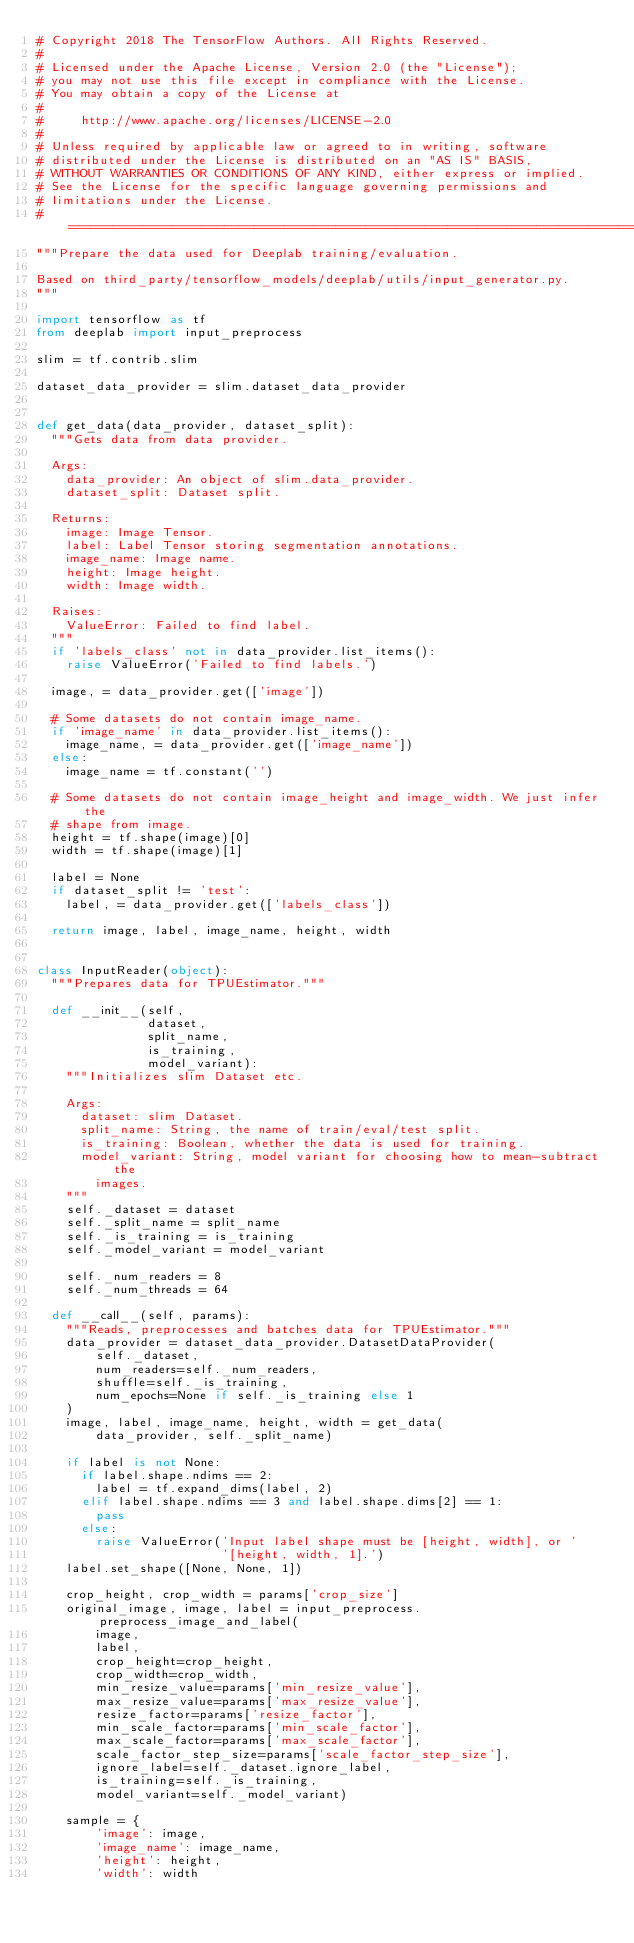<code> <loc_0><loc_0><loc_500><loc_500><_Python_># Copyright 2018 The TensorFlow Authors. All Rights Reserved.
#
# Licensed under the Apache License, Version 2.0 (the "License");
# you may not use this file except in compliance with the License.
# You may obtain a copy of the License at
#
#     http://www.apache.org/licenses/LICENSE-2.0
#
# Unless required by applicable law or agreed to in writing, software
# distributed under the License is distributed on an "AS IS" BASIS,
# WITHOUT WARRANTIES OR CONDITIONS OF ANY KIND, either express or implied.
# See the License for the specific language governing permissions and
# limitations under the License.
# ==============================================================================
"""Prepare the data used for Deeplab training/evaluation.

Based on third_party/tensorflow_models/deeplab/utils/input_generator.py.
"""

import tensorflow as tf
from deeplab import input_preprocess

slim = tf.contrib.slim

dataset_data_provider = slim.dataset_data_provider


def get_data(data_provider, dataset_split):
  """Gets data from data provider.

  Args:
    data_provider: An object of slim.data_provider.
    dataset_split: Dataset split.

  Returns:
    image: Image Tensor.
    label: Label Tensor storing segmentation annotations.
    image_name: Image name.
    height: Image height.
    width: Image width.

  Raises:
    ValueError: Failed to find label.
  """
  if 'labels_class' not in data_provider.list_items():
    raise ValueError('Failed to find labels.')

  image, = data_provider.get(['image'])

  # Some datasets do not contain image_name.
  if 'image_name' in data_provider.list_items():
    image_name, = data_provider.get(['image_name'])
  else:
    image_name = tf.constant('')

  # Some datasets do not contain image_height and image_width. We just infer the
  # shape from image.
  height = tf.shape(image)[0]
  width = tf.shape(image)[1]

  label = None
  if dataset_split != 'test':
    label, = data_provider.get(['labels_class'])

  return image, label, image_name, height, width


class InputReader(object):
  """Prepares data for TPUEstimator."""

  def __init__(self,
               dataset,
               split_name,
               is_training,
               model_variant):
    """Initializes slim Dataset etc.

    Args:
      dataset: slim Dataset.
      split_name: String, the name of train/eval/test split.
      is_training: Boolean, whether the data is used for training.
      model_variant: String, model variant for choosing how to mean-subtract the
        images.
    """
    self._dataset = dataset
    self._split_name = split_name
    self._is_training = is_training
    self._model_variant = model_variant

    self._num_readers = 8
    self._num_threads = 64

  def __call__(self, params):
    """Reads, preprocesses and batches data for TPUEstimator."""
    data_provider = dataset_data_provider.DatasetDataProvider(
        self._dataset,
        num_readers=self._num_readers,
        shuffle=self._is_training,
        num_epochs=None if self._is_training else 1
    )
    image, label, image_name, height, width = get_data(
        data_provider, self._split_name)

    if label is not None:
      if label.shape.ndims == 2:
        label = tf.expand_dims(label, 2)
      elif label.shape.ndims == 3 and label.shape.dims[2] == 1:
        pass
      else:
        raise ValueError('Input label shape must be [height, width], or '
                         '[height, width, 1].')
    label.set_shape([None, None, 1])

    crop_height, crop_width = params['crop_size']
    original_image, image, label = input_preprocess.preprocess_image_and_label(
        image,
        label,
        crop_height=crop_height,
        crop_width=crop_width,
        min_resize_value=params['min_resize_value'],
        max_resize_value=params['max_resize_value'],
        resize_factor=params['resize_factor'],
        min_scale_factor=params['min_scale_factor'],
        max_scale_factor=params['max_scale_factor'],
        scale_factor_step_size=params['scale_factor_step_size'],
        ignore_label=self._dataset.ignore_label,
        is_training=self._is_training,
        model_variant=self._model_variant)

    sample = {
        'image': image,
        'image_name': image_name,
        'height': height,
        'width': width</code> 